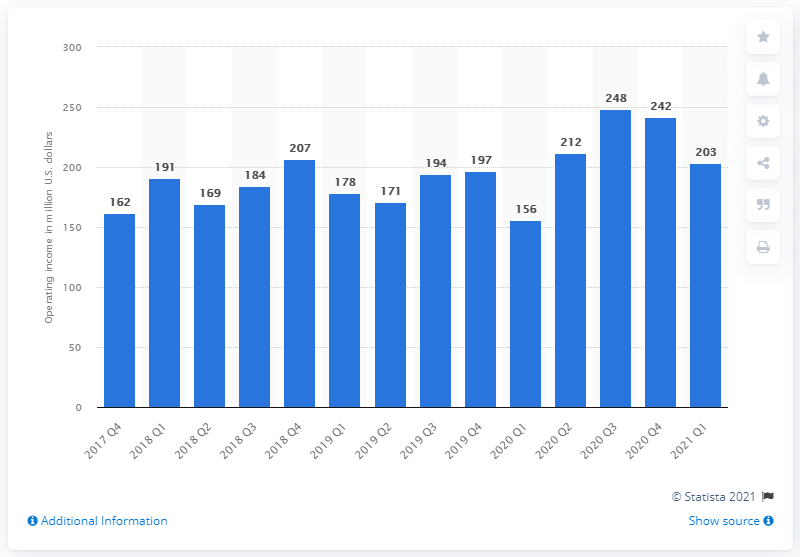Identify some key points in this picture. In the first quarter of 2021, King generated operating income. 